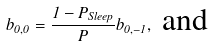Convert formula to latex. <formula><loc_0><loc_0><loc_500><loc_500>b _ { 0 , 0 } = \frac { 1 - P _ { S l e e p } } { P } b _ { 0 , - 1 } , \text { and}</formula> 